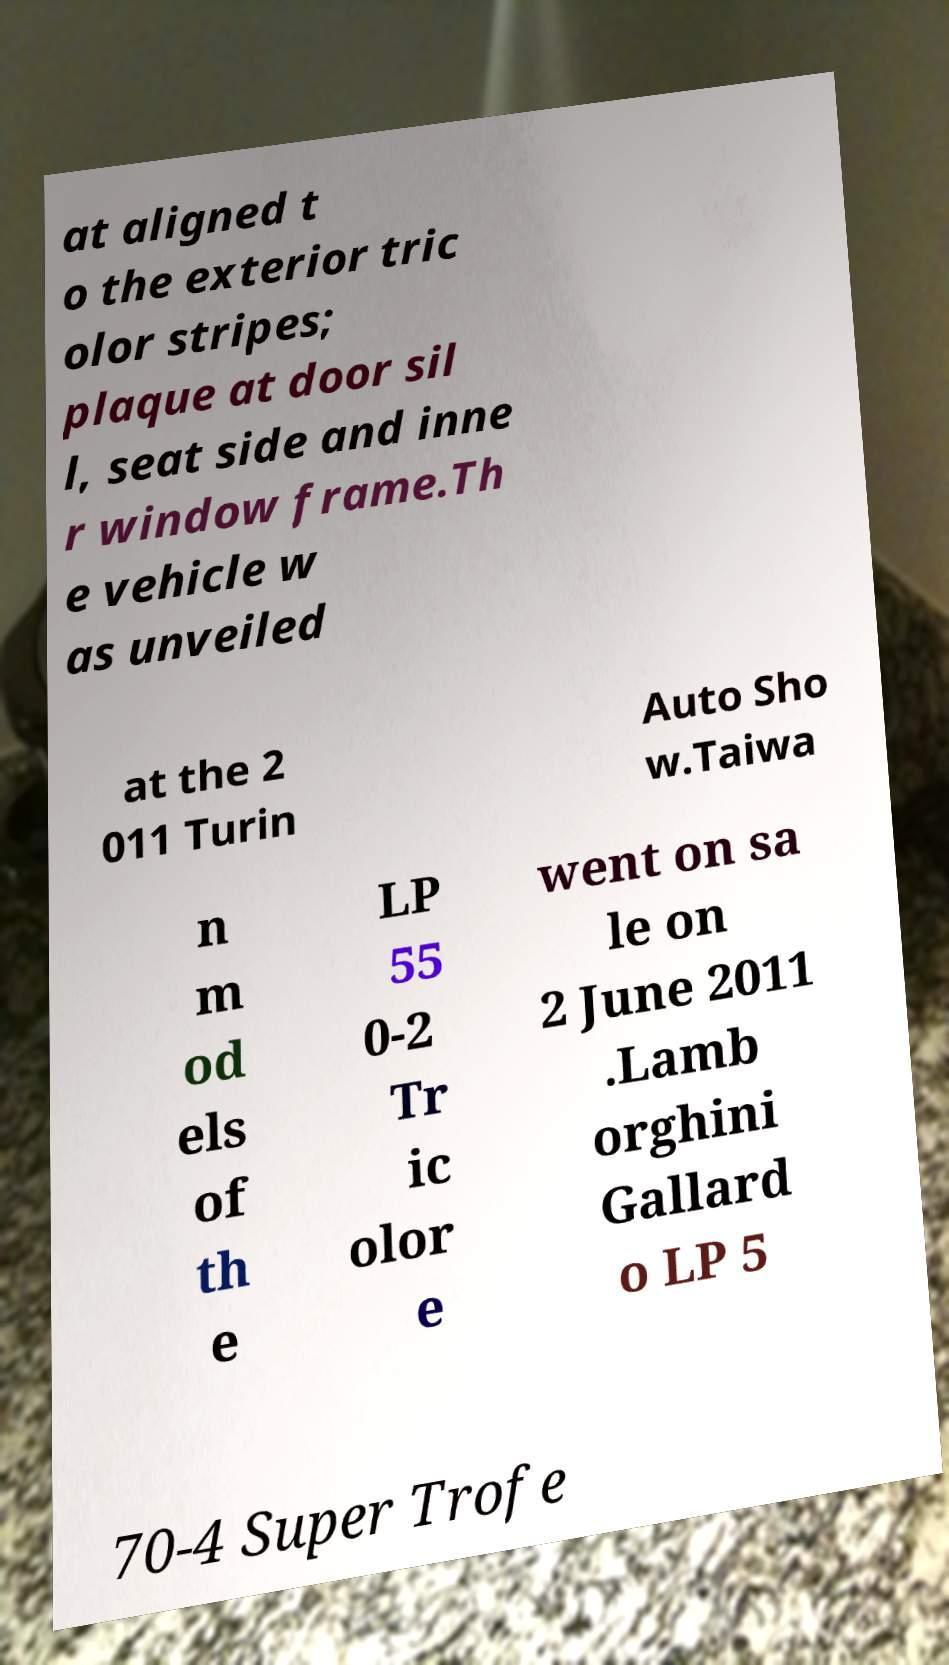Can you accurately transcribe the text from the provided image for me? at aligned t o the exterior tric olor stripes; plaque at door sil l, seat side and inne r window frame.Th e vehicle w as unveiled at the 2 011 Turin Auto Sho w.Taiwa n m od els of th e LP 55 0-2 Tr ic olor e went on sa le on 2 June 2011 .Lamb orghini Gallard o LP 5 70-4 Super Trofe 